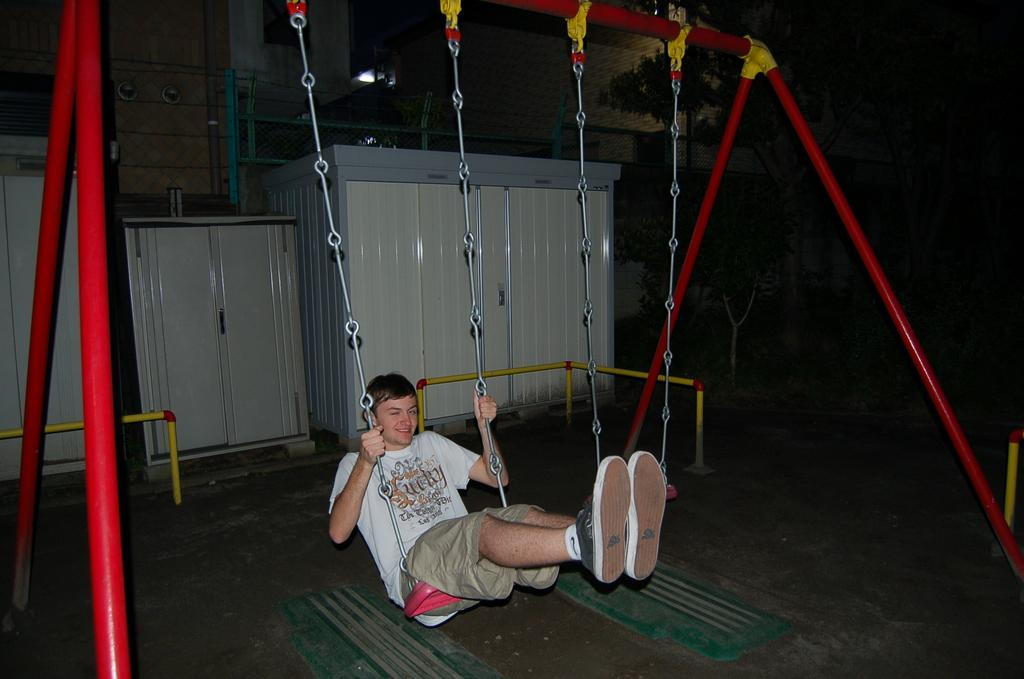What is the main subject of the image? The main subject of the image is a man. What is the man wearing in the image? The man is wearing a white t-shirt. What is the man doing in the image? The man is swinging. What can be seen in the background of the image? There are cupboards in the background of the image. Can you see a goose playing volleyball with the man in the image? No, there is no goose or volleyball present in the image. Is there a turkey visible in the image? No, there is no turkey visible in the image. 